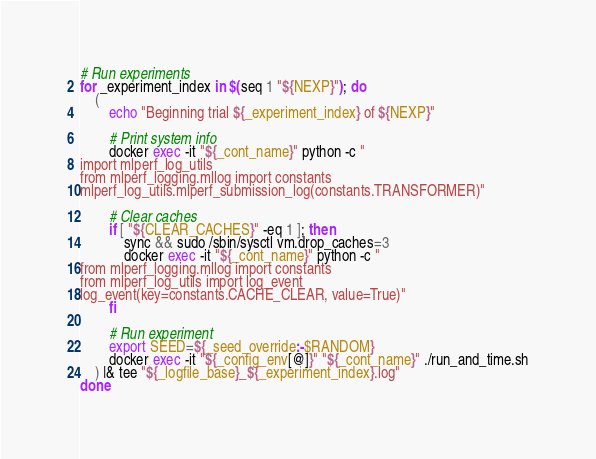Convert code to text. <code><loc_0><loc_0><loc_500><loc_500><_Bash_># Run experiments
for _experiment_index in $(seq 1 "${NEXP}"); do
    (
        echo "Beginning trial ${_experiment_index} of ${NEXP}"

        # Print system info
        docker exec -it "${_cont_name}" python -c "
import mlperf_log_utils
from mlperf_logging.mllog import constants
mlperf_log_utils.mlperf_submission_log(constants.TRANSFORMER)"

        # Clear caches
        if [ "${CLEAR_CACHES}" -eq 1 ]; then
            sync && sudo /sbin/sysctl vm.drop_caches=3
            docker exec -it "${_cont_name}" python -c "
from mlperf_logging.mllog import constants
from mlperf_log_utils import log_event
log_event(key=constants.CACHE_CLEAR, value=True)"
        fi

        # Run experiment
        export SEED=${_seed_override:-$RANDOM}
        docker exec -it "${_config_env[@]}" "${_cont_name}" ./run_and_time.sh
    ) |& tee "${_logfile_base}_${_experiment_index}.log"
done
</code> 